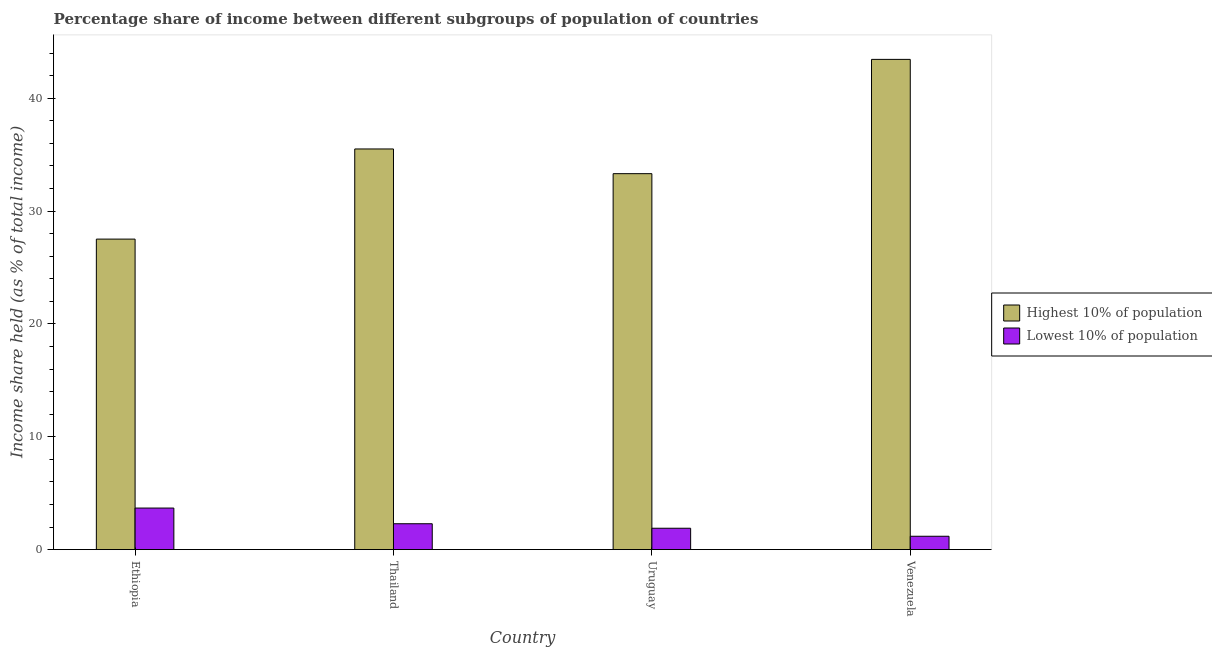How many groups of bars are there?
Keep it short and to the point. 4. Are the number of bars per tick equal to the number of legend labels?
Your response must be concise. Yes. Are the number of bars on each tick of the X-axis equal?
Offer a terse response. Yes. How many bars are there on the 2nd tick from the right?
Ensure brevity in your answer.  2. What is the label of the 3rd group of bars from the left?
Provide a short and direct response. Uruguay. What is the income share held by highest 10% of the population in Venezuela?
Offer a terse response. 43.45. Across all countries, what is the maximum income share held by lowest 10% of the population?
Your response must be concise. 3.68. Across all countries, what is the minimum income share held by lowest 10% of the population?
Provide a succinct answer. 1.18. In which country was the income share held by lowest 10% of the population maximum?
Keep it short and to the point. Ethiopia. In which country was the income share held by lowest 10% of the population minimum?
Your response must be concise. Venezuela. What is the total income share held by lowest 10% of the population in the graph?
Offer a terse response. 9.04. What is the difference between the income share held by lowest 10% of the population in Thailand and the income share held by highest 10% of the population in Ethiopia?
Provide a short and direct response. -25.23. What is the average income share held by highest 10% of the population per country?
Give a very brief answer. 34.95. What is the difference between the income share held by lowest 10% of the population and income share held by highest 10% of the population in Ethiopia?
Your answer should be very brief. -23.84. In how many countries, is the income share held by lowest 10% of the population greater than 28 %?
Offer a terse response. 0. What is the ratio of the income share held by lowest 10% of the population in Thailand to that in Uruguay?
Keep it short and to the point. 1.21. Is the difference between the income share held by lowest 10% of the population in Thailand and Uruguay greater than the difference between the income share held by highest 10% of the population in Thailand and Uruguay?
Your answer should be compact. No. What is the difference between the highest and the second highest income share held by highest 10% of the population?
Keep it short and to the point. 7.94. What is the difference between the highest and the lowest income share held by lowest 10% of the population?
Provide a succinct answer. 2.5. In how many countries, is the income share held by highest 10% of the population greater than the average income share held by highest 10% of the population taken over all countries?
Offer a very short reply. 2. Is the sum of the income share held by lowest 10% of the population in Ethiopia and Uruguay greater than the maximum income share held by highest 10% of the population across all countries?
Your answer should be very brief. No. What does the 1st bar from the left in Thailand represents?
Keep it short and to the point. Highest 10% of population. What does the 2nd bar from the right in Ethiopia represents?
Ensure brevity in your answer.  Highest 10% of population. How many bars are there?
Your answer should be compact. 8. Are all the bars in the graph horizontal?
Offer a very short reply. No. How many countries are there in the graph?
Offer a very short reply. 4. What is the difference between two consecutive major ticks on the Y-axis?
Provide a succinct answer. 10. Does the graph contain grids?
Your answer should be compact. No. How many legend labels are there?
Ensure brevity in your answer.  2. What is the title of the graph?
Your answer should be compact. Percentage share of income between different subgroups of population of countries. What is the label or title of the Y-axis?
Give a very brief answer. Income share held (as % of total income). What is the Income share held (as % of total income) in Highest 10% of population in Ethiopia?
Your answer should be very brief. 27.52. What is the Income share held (as % of total income) in Lowest 10% of population in Ethiopia?
Ensure brevity in your answer.  3.68. What is the Income share held (as % of total income) of Highest 10% of population in Thailand?
Your answer should be compact. 35.51. What is the Income share held (as % of total income) of Lowest 10% of population in Thailand?
Offer a terse response. 2.29. What is the Income share held (as % of total income) in Highest 10% of population in Uruguay?
Offer a very short reply. 33.32. What is the Income share held (as % of total income) of Lowest 10% of population in Uruguay?
Ensure brevity in your answer.  1.89. What is the Income share held (as % of total income) of Highest 10% of population in Venezuela?
Your response must be concise. 43.45. What is the Income share held (as % of total income) of Lowest 10% of population in Venezuela?
Make the answer very short. 1.18. Across all countries, what is the maximum Income share held (as % of total income) of Highest 10% of population?
Provide a succinct answer. 43.45. Across all countries, what is the maximum Income share held (as % of total income) in Lowest 10% of population?
Offer a terse response. 3.68. Across all countries, what is the minimum Income share held (as % of total income) of Highest 10% of population?
Offer a terse response. 27.52. Across all countries, what is the minimum Income share held (as % of total income) of Lowest 10% of population?
Give a very brief answer. 1.18. What is the total Income share held (as % of total income) in Highest 10% of population in the graph?
Keep it short and to the point. 139.8. What is the total Income share held (as % of total income) of Lowest 10% of population in the graph?
Provide a short and direct response. 9.04. What is the difference between the Income share held (as % of total income) in Highest 10% of population in Ethiopia and that in Thailand?
Offer a terse response. -7.99. What is the difference between the Income share held (as % of total income) in Lowest 10% of population in Ethiopia and that in Thailand?
Provide a short and direct response. 1.39. What is the difference between the Income share held (as % of total income) in Lowest 10% of population in Ethiopia and that in Uruguay?
Give a very brief answer. 1.79. What is the difference between the Income share held (as % of total income) in Highest 10% of population in Ethiopia and that in Venezuela?
Ensure brevity in your answer.  -15.93. What is the difference between the Income share held (as % of total income) in Lowest 10% of population in Ethiopia and that in Venezuela?
Ensure brevity in your answer.  2.5. What is the difference between the Income share held (as % of total income) in Highest 10% of population in Thailand and that in Uruguay?
Offer a very short reply. 2.19. What is the difference between the Income share held (as % of total income) of Highest 10% of population in Thailand and that in Venezuela?
Offer a very short reply. -7.94. What is the difference between the Income share held (as % of total income) of Lowest 10% of population in Thailand and that in Venezuela?
Make the answer very short. 1.11. What is the difference between the Income share held (as % of total income) in Highest 10% of population in Uruguay and that in Venezuela?
Your answer should be compact. -10.13. What is the difference between the Income share held (as % of total income) in Lowest 10% of population in Uruguay and that in Venezuela?
Give a very brief answer. 0.71. What is the difference between the Income share held (as % of total income) of Highest 10% of population in Ethiopia and the Income share held (as % of total income) of Lowest 10% of population in Thailand?
Give a very brief answer. 25.23. What is the difference between the Income share held (as % of total income) of Highest 10% of population in Ethiopia and the Income share held (as % of total income) of Lowest 10% of population in Uruguay?
Your answer should be compact. 25.63. What is the difference between the Income share held (as % of total income) of Highest 10% of population in Ethiopia and the Income share held (as % of total income) of Lowest 10% of population in Venezuela?
Provide a succinct answer. 26.34. What is the difference between the Income share held (as % of total income) in Highest 10% of population in Thailand and the Income share held (as % of total income) in Lowest 10% of population in Uruguay?
Keep it short and to the point. 33.62. What is the difference between the Income share held (as % of total income) in Highest 10% of population in Thailand and the Income share held (as % of total income) in Lowest 10% of population in Venezuela?
Offer a very short reply. 34.33. What is the difference between the Income share held (as % of total income) of Highest 10% of population in Uruguay and the Income share held (as % of total income) of Lowest 10% of population in Venezuela?
Provide a succinct answer. 32.14. What is the average Income share held (as % of total income) of Highest 10% of population per country?
Your answer should be very brief. 34.95. What is the average Income share held (as % of total income) of Lowest 10% of population per country?
Make the answer very short. 2.26. What is the difference between the Income share held (as % of total income) in Highest 10% of population and Income share held (as % of total income) in Lowest 10% of population in Ethiopia?
Make the answer very short. 23.84. What is the difference between the Income share held (as % of total income) in Highest 10% of population and Income share held (as % of total income) in Lowest 10% of population in Thailand?
Make the answer very short. 33.22. What is the difference between the Income share held (as % of total income) of Highest 10% of population and Income share held (as % of total income) of Lowest 10% of population in Uruguay?
Offer a terse response. 31.43. What is the difference between the Income share held (as % of total income) of Highest 10% of population and Income share held (as % of total income) of Lowest 10% of population in Venezuela?
Keep it short and to the point. 42.27. What is the ratio of the Income share held (as % of total income) in Highest 10% of population in Ethiopia to that in Thailand?
Your answer should be very brief. 0.78. What is the ratio of the Income share held (as % of total income) in Lowest 10% of population in Ethiopia to that in Thailand?
Your answer should be compact. 1.61. What is the ratio of the Income share held (as % of total income) of Highest 10% of population in Ethiopia to that in Uruguay?
Your answer should be very brief. 0.83. What is the ratio of the Income share held (as % of total income) of Lowest 10% of population in Ethiopia to that in Uruguay?
Keep it short and to the point. 1.95. What is the ratio of the Income share held (as % of total income) of Highest 10% of population in Ethiopia to that in Venezuela?
Keep it short and to the point. 0.63. What is the ratio of the Income share held (as % of total income) in Lowest 10% of population in Ethiopia to that in Venezuela?
Offer a very short reply. 3.12. What is the ratio of the Income share held (as % of total income) of Highest 10% of population in Thailand to that in Uruguay?
Your answer should be compact. 1.07. What is the ratio of the Income share held (as % of total income) of Lowest 10% of population in Thailand to that in Uruguay?
Provide a succinct answer. 1.21. What is the ratio of the Income share held (as % of total income) in Highest 10% of population in Thailand to that in Venezuela?
Your response must be concise. 0.82. What is the ratio of the Income share held (as % of total income) in Lowest 10% of population in Thailand to that in Venezuela?
Your answer should be very brief. 1.94. What is the ratio of the Income share held (as % of total income) in Highest 10% of population in Uruguay to that in Venezuela?
Make the answer very short. 0.77. What is the ratio of the Income share held (as % of total income) in Lowest 10% of population in Uruguay to that in Venezuela?
Keep it short and to the point. 1.6. What is the difference between the highest and the second highest Income share held (as % of total income) of Highest 10% of population?
Your answer should be compact. 7.94. What is the difference between the highest and the second highest Income share held (as % of total income) of Lowest 10% of population?
Your answer should be very brief. 1.39. What is the difference between the highest and the lowest Income share held (as % of total income) of Highest 10% of population?
Give a very brief answer. 15.93. What is the difference between the highest and the lowest Income share held (as % of total income) of Lowest 10% of population?
Provide a short and direct response. 2.5. 